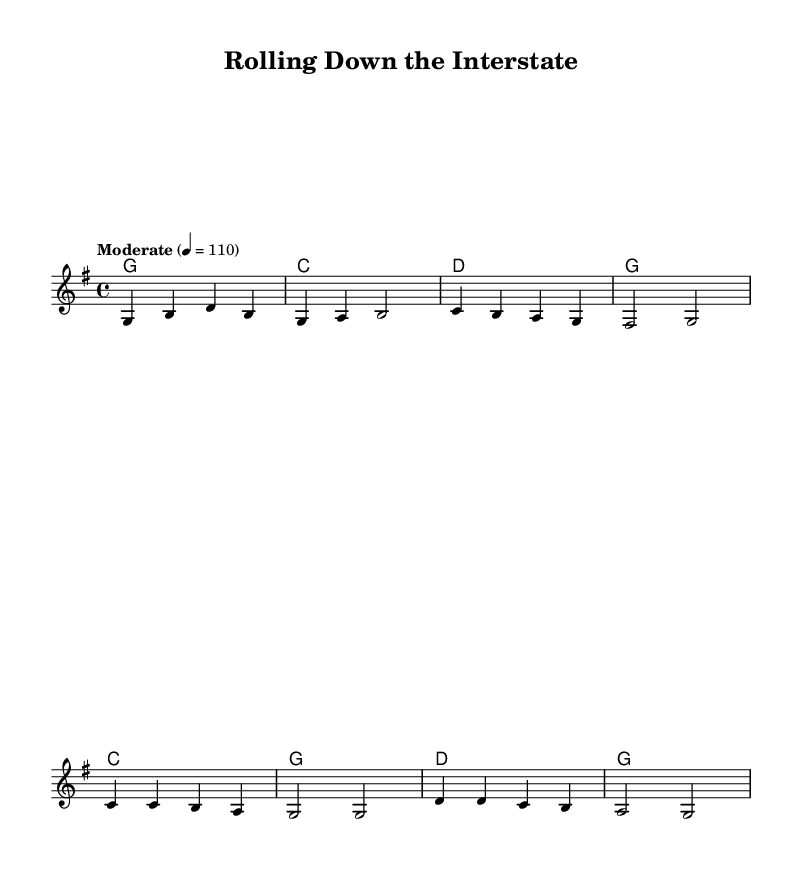What is the key signature of this music? The key signature is indicated by the presence of one sharp, which corresponds to G major.
Answer: G major What is the time signature of this piece? The time signature is located at the beginning of the music, where it shows a '4/4' symbol, indicating four beats per measure.
Answer: 4/4 What is the tempo marking for this composition? The tempo is given in the layout with the term “Moderate” and is set to 110 beats per minute, indicating a moderate pace.
Answer: 110 How many lines are there in the chorus lyrics? The chorus lyrics are structured in four lines, as indicated by the layout of the words under the melody in the sheet music.
Answer: Four lines What is the first word of the first verse? The first verse starts with the word "Eighteen," as indicated in the lyrics corresponding to the melody.
Answer: Eighteen How does the harmony change from the verse to the chorus? In the verse, the harmony starts with G major, followed by C major and D major, while the chorus primarily uses C major and G major, creating a contrast in progression.
Answer: G major to C major What theme is expressed in the lyrics of this song? The lyrics focus on the life of a long-haul truck driver, highlighting aspects of freedom, travel, and the connection to American highways, reflecting the country rock genre.
Answer: Long-haul trucking 